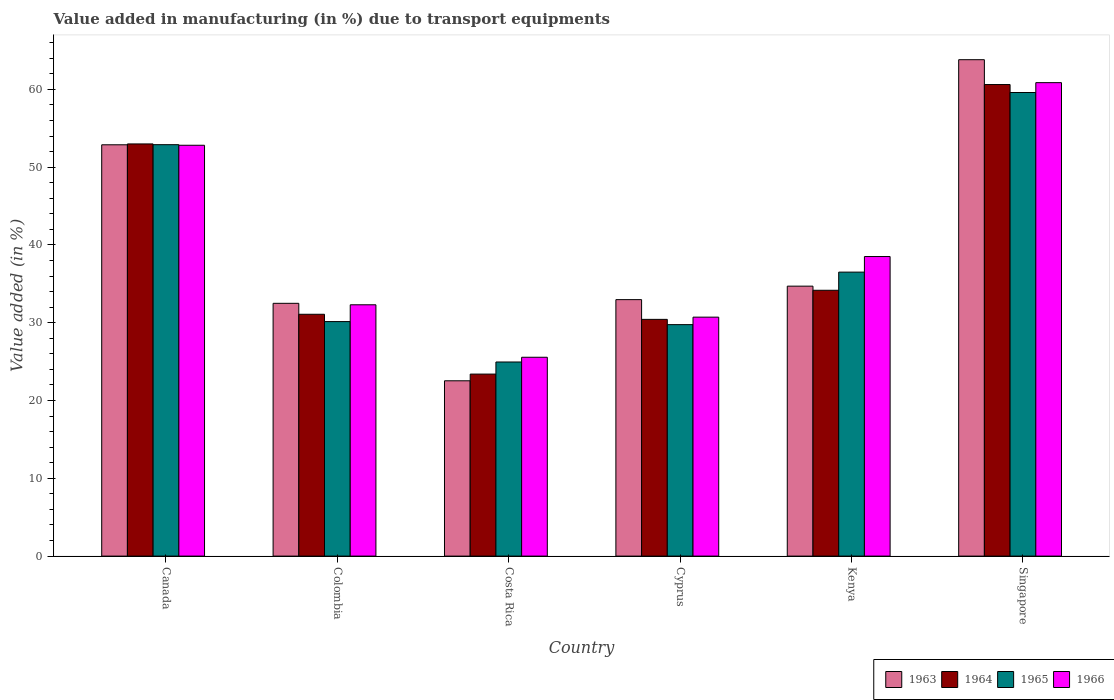How many different coloured bars are there?
Offer a terse response. 4. How many groups of bars are there?
Give a very brief answer. 6. Are the number of bars on each tick of the X-axis equal?
Give a very brief answer. Yes. How many bars are there on the 4th tick from the right?
Your answer should be compact. 4. What is the percentage of value added in manufacturing due to transport equipments in 1966 in Canada?
Keep it short and to the point. 52.81. Across all countries, what is the maximum percentage of value added in manufacturing due to transport equipments in 1964?
Provide a short and direct response. 60.62. Across all countries, what is the minimum percentage of value added in manufacturing due to transport equipments in 1966?
Your answer should be very brief. 25.56. In which country was the percentage of value added in manufacturing due to transport equipments in 1965 maximum?
Your answer should be compact. Singapore. What is the total percentage of value added in manufacturing due to transport equipments in 1966 in the graph?
Provide a succinct answer. 240.76. What is the difference between the percentage of value added in manufacturing due to transport equipments in 1966 in Canada and that in Kenya?
Ensure brevity in your answer.  14.3. What is the difference between the percentage of value added in manufacturing due to transport equipments in 1965 in Costa Rica and the percentage of value added in manufacturing due to transport equipments in 1963 in Singapore?
Provide a succinct answer. -38.86. What is the average percentage of value added in manufacturing due to transport equipments in 1966 per country?
Your answer should be compact. 40.13. What is the difference between the percentage of value added in manufacturing due to transport equipments of/in 1963 and percentage of value added in manufacturing due to transport equipments of/in 1964 in Costa Rica?
Provide a short and direct response. -0.86. In how many countries, is the percentage of value added in manufacturing due to transport equipments in 1964 greater than 52 %?
Give a very brief answer. 2. What is the ratio of the percentage of value added in manufacturing due to transport equipments in 1963 in Colombia to that in Singapore?
Provide a short and direct response. 0.51. What is the difference between the highest and the second highest percentage of value added in manufacturing due to transport equipments in 1964?
Ensure brevity in your answer.  -26.45. What is the difference between the highest and the lowest percentage of value added in manufacturing due to transport equipments in 1966?
Ensure brevity in your answer.  35.3. Is it the case that in every country, the sum of the percentage of value added in manufacturing due to transport equipments in 1965 and percentage of value added in manufacturing due to transport equipments in 1966 is greater than the sum of percentage of value added in manufacturing due to transport equipments in 1964 and percentage of value added in manufacturing due to transport equipments in 1963?
Offer a very short reply. No. What does the 3rd bar from the left in Costa Rica represents?
Your response must be concise. 1965. What does the 1st bar from the right in Singapore represents?
Offer a very short reply. 1966. How many bars are there?
Your response must be concise. 24. Are all the bars in the graph horizontal?
Provide a succinct answer. No. How many countries are there in the graph?
Provide a short and direct response. 6. Does the graph contain grids?
Your response must be concise. No. How are the legend labels stacked?
Give a very brief answer. Horizontal. What is the title of the graph?
Offer a very short reply. Value added in manufacturing (in %) due to transport equipments. Does "2013" appear as one of the legend labels in the graph?
Offer a very short reply. No. What is the label or title of the X-axis?
Ensure brevity in your answer.  Country. What is the label or title of the Y-axis?
Make the answer very short. Value added (in %). What is the Value added (in %) of 1963 in Canada?
Offer a very short reply. 52.87. What is the Value added (in %) of 1964 in Canada?
Ensure brevity in your answer.  52.98. What is the Value added (in %) of 1965 in Canada?
Make the answer very short. 52.89. What is the Value added (in %) of 1966 in Canada?
Provide a succinct answer. 52.81. What is the Value added (in %) in 1963 in Colombia?
Your answer should be compact. 32.49. What is the Value added (in %) in 1964 in Colombia?
Ensure brevity in your answer.  31.09. What is the Value added (in %) of 1965 in Colombia?
Provide a short and direct response. 30.15. What is the Value added (in %) in 1966 in Colombia?
Offer a terse response. 32.3. What is the Value added (in %) of 1963 in Costa Rica?
Your answer should be very brief. 22.53. What is the Value added (in %) of 1964 in Costa Rica?
Give a very brief answer. 23.4. What is the Value added (in %) in 1965 in Costa Rica?
Make the answer very short. 24.95. What is the Value added (in %) of 1966 in Costa Rica?
Make the answer very short. 25.56. What is the Value added (in %) in 1963 in Cyprus?
Offer a terse response. 32.97. What is the Value added (in %) in 1964 in Cyprus?
Ensure brevity in your answer.  30.43. What is the Value added (in %) in 1965 in Cyprus?
Keep it short and to the point. 29.75. What is the Value added (in %) of 1966 in Cyprus?
Offer a terse response. 30.72. What is the Value added (in %) in 1963 in Kenya?
Offer a very short reply. 34.7. What is the Value added (in %) of 1964 in Kenya?
Provide a short and direct response. 34.17. What is the Value added (in %) of 1965 in Kenya?
Ensure brevity in your answer.  36.5. What is the Value added (in %) of 1966 in Kenya?
Make the answer very short. 38.51. What is the Value added (in %) in 1963 in Singapore?
Provide a succinct answer. 63.81. What is the Value added (in %) in 1964 in Singapore?
Provide a succinct answer. 60.62. What is the Value added (in %) of 1965 in Singapore?
Your answer should be compact. 59.59. What is the Value added (in %) of 1966 in Singapore?
Ensure brevity in your answer.  60.86. Across all countries, what is the maximum Value added (in %) of 1963?
Your answer should be very brief. 63.81. Across all countries, what is the maximum Value added (in %) in 1964?
Ensure brevity in your answer.  60.62. Across all countries, what is the maximum Value added (in %) in 1965?
Your response must be concise. 59.59. Across all countries, what is the maximum Value added (in %) in 1966?
Ensure brevity in your answer.  60.86. Across all countries, what is the minimum Value added (in %) in 1963?
Make the answer very short. 22.53. Across all countries, what is the minimum Value added (in %) in 1964?
Give a very brief answer. 23.4. Across all countries, what is the minimum Value added (in %) in 1965?
Provide a succinct answer. 24.95. Across all countries, what is the minimum Value added (in %) of 1966?
Your answer should be compact. 25.56. What is the total Value added (in %) in 1963 in the graph?
Keep it short and to the point. 239.38. What is the total Value added (in %) in 1964 in the graph?
Provide a succinct answer. 232.68. What is the total Value added (in %) in 1965 in the graph?
Provide a short and direct response. 233.83. What is the total Value added (in %) of 1966 in the graph?
Make the answer very short. 240.76. What is the difference between the Value added (in %) in 1963 in Canada and that in Colombia?
Your response must be concise. 20.38. What is the difference between the Value added (in %) in 1964 in Canada and that in Colombia?
Ensure brevity in your answer.  21.9. What is the difference between the Value added (in %) of 1965 in Canada and that in Colombia?
Offer a very short reply. 22.74. What is the difference between the Value added (in %) of 1966 in Canada and that in Colombia?
Keep it short and to the point. 20.51. What is the difference between the Value added (in %) of 1963 in Canada and that in Costa Rica?
Ensure brevity in your answer.  30.34. What is the difference between the Value added (in %) of 1964 in Canada and that in Costa Rica?
Your answer should be compact. 29.59. What is the difference between the Value added (in %) in 1965 in Canada and that in Costa Rica?
Ensure brevity in your answer.  27.93. What is the difference between the Value added (in %) of 1966 in Canada and that in Costa Rica?
Keep it short and to the point. 27.25. What is the difference between the Value added (in %) of 1963 in Canada and that in Cyprus?
Your answer should be very brief. 19.91. What is the difference between the Value added (in %) of 1964 in Canada and that in Cyprus?
Give a very brief answer. 22.55. What is the difference between the Value added (in %) in 1965 in Canada and that in Cyprus?
Your response must be concise. 23.13. What is the difference between the Value added (in %) of 1966 in Canada and that in Cyprus?
Provide a short and direct response. 22.1. What is the difference between the Value added (in %) in 1963 in Canada and that in Kenya?
Offer a terse response. 18.17. What is the difference between the Value added (in %) in 1964 in Canada and that in Kenya?
Your answer should be compact. 18.81. What is the difference between the Value added (in %) in 1965 in Canada and that in Kenya?
Your answer should be very brief. 16.38. What is the difference between the Value added (in %) in 1966 in Canada and that in Kenya?
Keep it short and to the point. 14.3. What is the difference between the Value added (in %) of 1963 in Canada and that in Singapore?
Provide a short and direct response. -10.94. What is the difference between the Value added (in %) of 1964 in Canada and that in Singapore?
Ensure brevity in your answer.  -7.63. What is the difference between the Value added (in %) of 1965 in Canada and that in Singapore?
Provide a succinct answer. -6.71. What is the difference between the Value added (in %) of 1966 in Canada and that in Singapore?
Ensure brevity in your answer.  -8.05. What is the difference between the Value added (in %) in 1963 in Colombia and that in Costa Rica?
Offer a terse response. 9.96. What is the difference between the Value added (in %) in 1964 in Colombia and that in Costa Rica?
Provide a succinct answer. 7.69. What is the difference between the Value added (in %) in 1965 in Colombia and that in Costa Rica?
Offer a very short reply. 5.2. What is the difference between the Value added (in %) in 1966 in Colombia and that in Costa Rica?
Keep it short and to the point. 6.74. What is the difference between the Value added (in %) in 1963 in Colombia and that in Cyprus?
Make the answer very short. -0.47. What is the difference between the Value added (in %) of 1964 in Colombia and that in Cyprus?
Keep it short and to the point. 0.66. What is the difference between the Value added (in %) of 1965 in Colombia and that in Cyprus?
Your answer should be compact. 0.39. What is the difference between the Value added (in %) of 1966 in Colombia and that in Cyprus?
Give a very brief answer. 1.59. What is the difference between the Value added (in %) in 1963 in Colombia and that in Kenya?
Offer a terse response. -2.21. What is the difference between the Value added (in %) of 1964 in Colombia and that in Kenya?
Offer a very short reply. -3.08. What is the difference between the Value added (in %) of 1965 in Colombia and that in Kenya?
Your answer should be compact. -6.36. What is the difference between the Value added (in %) in 1966 in Colombia and that in Kenya?
Make the answer very short. -6.2. What is the difference between the Value added (in %) of 1963 in Colombia and that in Singapore?
Ensure brevity in your answer.  -31.32. What is the difference between the Value added (in %) of 1964 in Colombia and that in Singapore?
Your answer should be compact. -29.53. What is the difference between the Value added (in %) of 1965 in Colombia and that in Singapore?
Provide a succinct answer. -29.45. What is the difference between the Value added (in %) in 1966 in Colombia and that in Singapore?
Give a very brief answer. -28.56. What is the difference between the Value added (in %) of 1963 in Costa Rica and that in Cyprus?
Your answer should be very brief. -10.43. What is the difference between the Value added (in %) in 1964 in Costa Rica and that in Cyprus?
Your response must be concise. -7.03. What is the difference between the Value added (in %) in 1965 in Costa Rica and that in Cyprus?
Offer a very short reply. -4.8. What is the difference between the Value added (in %) in 1966 in Costa Rica and that in Cyprus?
Give a very brief answer. -5.16. What is the difference between the Value added (in %) in 1963 in Costa Rica and that in Kenya?
Provide a short and direct response. -12.17. What is the difference between the Value added (in %) in 1964 in Costa Rica and that in Kenya?
Your response must be concise. -10.77. What is the difference between the Value added (in %) of 1965 in Costa Rica and that in Kenya?
Ensure brevity in your answer.  -11.55. What is the difference between the Value added (in %) of 1966 in Costa Rica and that in Kenya?
Your response must be concise. -12.95. What is the difference between the Value added (in %) of 1963 in Costa Rica and that in Singapore?
Keep it short and to the point. -41.28. What is the difference between the Value added (in %) of 1964 in Costa Rica and that in Singapore?
Ensure brevity in your answer.  -37.22. What is the difference between the Value added (in %) in 1965 in Costa Rica and that in Singapore?
Your answer should be very brief. -34.64. What is the difference between the Value added (in %) in 1966 in Costa Rica and that in Singapore?
Your answer should be very brief. -35.3. What is the difference between the Value added (in %) of 1963 in Cyprus and that in Kenya?
Ensure brevity in your answer.  -1.73. What is the difference between the Value added (in %) of 1964 in Cyprus and that in Kenya?
Keep it short and to the point. -3.74. What is the difference between the Value added (in %) of 1965 in Cyprus and that in Kenya?
Provide a short and direct response. -6.75. What is the difference between the Value added (in %) of 1966 in Cyprus and that in Kenya?
Your response must be concise. -7.79. What is the difference between the Value added (in %) in 1963 in Cyprus and that in Singapore?
Provide a succinct answer. -30.84. What is the difference between the Value added (in %) of 1964 in Cyprus and that in Singapore?
Ensure brevity in your answer.  -30.19. What is the difference between the Value added (in %) of 1965 in Cyprus and that in Singapore?
Ensure brevity in your answer.  -29.84. What is the difference between the Value added (in %) of 1966 in Cyprus and that in Singapore?
Your response must be concise. -30.14. What is the difference between the Value added (in %) in 1963 in Kenya and that in Singapore?
Keep it short and to the point. -29.11. What is the difference between the Value added (in %) of 1964 in Kenya and that in Singapore?
Your answer should be compact. -26.45. What is the difference between the Value added (in %) in 1965 in Kenya and that in Singapore?
Give a very brief answer. -23.09. What is the difference between the Value added (in %) of 1966 in Kenya and that in Singapore?
Offer a terse response. -22.35. What is the difference between the Value added (in %) in 1963 in Canada and the Value added (in %) in 1964 in Colombia?
Keep it short and to the point. 21.79. What is the difference between the Value added (in %) of 1963 in Canada and the Value added (in %) of 1965 in Colombia?
Offer a very short reply. 22.73. What is the difference between the Value added (in %) in 1963 in Canada and the Value added (in %) in 1966 in Colombia?
Keep it short and to the point. 20.57. What is the difference between the Value added (in %) in 1964 in Canada and the Value added (in %) in 1965 in Colombia?
Keep it short and to the point. 22.84. What is the difference between the Value added (in %) in 1964 in Canada and the Value added (in %) in 1966 in Colombia?
Your response must be concise. 20.68. What is the difference between the Value added (in %) in 1965 in Canada and the Value added (in %) in 1966 in Colombia?
Your response must be concise. 20.58. What is the difference between the Value added (in %) of 1963 in Canada and the Value added (in %) of 1964 in Costa Rica?
Provide a short and direct response. 29.48. What is the difference between the Value added (in %) in 1963 in Canada and the Value added (in %) in 1965 in Costa Rica?
Keep it short and to the point. 27.92. What is the difference between the Value added (in %) in 1963 in Canada and the Value added (in %) in 1966 in Costa Rica?
Provide a short and direct response. 27.31. What is the difference between the Value added (in %) of 1964 in Canada and the Value added (in %) of 1965 in Costa Rica?
Your answer should be very brief. 28.03. What is the difference between the Value added (in %) of 1964 in Canada and the Value added (in %) of 1966 in Costa Rica?
Keep it short and to the point. 27.42. What is the difference between the Value added (in %) in 1965 in Canada and the Value added (in %) in 1966 in Costa Rica?
Keep it short and to the point. 27.33. What is the difference between the Value added (in %) in 1963 in Canada and the Value added (in %) in 1964 in Cyprus?
Your answer should be compact. 22.44. What is the difference between the Value added (in %) of 1963 in Canada and the Value added (in %) of 1965 in Cyprus?
Your response must be concise. 23.12. What is the difference between the Value added (in %) in 1963 in Canada and the Value added (in %) in 1966 in Cyprus?
Ensure brevity in your answer.  22.16. What is the difference between the Value added (in %) of 1964 in Canada and the Value added (in %) of 1965 in Cyprus?
Your answer should be very brief. 23.23. What is the difference between the Value added (in %) of 1964 in Canada and the Value added (in %) of 1966 in Cyprus?
Your answer should be compact. 22.27. What is the difference between the Value added (in %) of 1965 in Canada and the Value added (in %) of 1966 in Cyprus?
Keep it short and to the point. 22.17. What is the difference between the Value added (in %) in 1963 in Canada and the Value added (in %) in 1964 in Kenya?
Ensure brevity in your answer.  18.7. What is the difference between the Value added (in %) of 1963 in Canada and the Value added (in %) of 1965 in Kenya?
Offer a very short reply. 16.37. What is the difference between the Value added (in %) of 1963 in Canada and the Value added (in %) of 1966 in Kenya?
Provide a short and direct response. 14.37. What is the difference between the Value added (in %) in 1964 in Canada and the Value added (in %) in 1965 in Kenya?
Provide a short and direct response. 16.48. What is the difference between the Value added (in %) of 1964 in Canada and the Value added (in %) of 1966 in Kenya?
Offer a terse response. 14.47. What is the difference between the Value added (in %) of 1965 in Canada and the Value added (in %) of 1966 in Kenya?
Make the answer very short. 14.38. What is the difference between the Value added (in %) of 1963 in Canada and the Value added (in %) of 1964 in Singapore?
Your response must be concise. -7.74. What is the difference between the Value added (in %) of 1963 in Canada and the Value added (in %) of 1965 in Singapore?
Your response must be concise. -6.72. What is the difference between the Value added (in %) of 1963 in Canada and the Value added (in %) of 1966 in Singapore?
Keep it short and to the point. -7.99. What is the difference between the Value added (in %) in 1964 in Canada and the Value added (in %) in 1965 in Singapore?
Offer a very short reply. -6.61. What is the difference between the Value added (in %) in 1964 in Canada and the Value added (in %) in 1966 in Singapore?
Provide a succinct answer. -7.88. What is the difference between the Value added (in %) in 1965 in Canada and the Value added (in %) in 1966 in Singapore?
Ensure brevity in your answer.  -7.97. What is the difference between the Value added (in %) of 1963 in Colombia and the Value added (in %) of 1964 in Costa Rica?
Give a very brief answer. 9.1. What is the difference between the Value added (in %) of 1963 in Colombia and the Value added (in %) of 1965 in Costa Rica?
Offer a very short reply. 7.54. What is the difference between the Value added (in %) of 1963 in Colombia and the Value added (in %) of 1966 in Costa Rica?
Your answer should be compact. 6.93. What is the difference between the Value added (in %) of 1964 in Colombia and the Value added (in %) of 1965 in Costa Rica?
Your answer should be compact. 6.14. What is the difference between the Value added (in %) of 1964 in Colombia and the Value added (in %) of 1966 in Costa Rica?
Keep it short and to the point. 5.53. What is the difference between the Value added (in %) of 1965 in Colombia and the Value added (in %) of 1966 in Costa Rica?
Ensure brevity in your answer.  4.59. What is the difference between the Value added (in %) in 1963 in Colombia and the Value added (in %) in 1964 in Cyprus?
Offer a terse response. 2.06. What is the difference between the Value added (in %) in 1963 in Colombia and the Value added (in %) in 1965 in Cyprus?
Ensure brevity in your answer.  2.74. What is the difference between the Value added (in %) of 1963 in Colombia and the Value added (in %) of 1966 in Cyprus?
Offer a very short reply. 1.78. What is the difference between the Value added (in %) of 1964 in Colombia and the Value added (in %) of 1965 in Cyprus?
Provide a short and direct response. 1.33. What is the difference between the Value added (in %) of 1964 in Colombia and the Value added (in %) of 1966 in Cyprus?
Make the answer very short. 0.37. What is the difference between the Value added (in %) of 1965 in Colombia and the Value added (in %) of 1966 in Cyprus?
Make the answer very short. -0.57. What is the difference between the Value added (in %) in 1963 in Colombia and the Value added (in %) in 1964 in Kenya?
Give a very brief answer. -1.68. What is the difference between the Value added (in %) in 1963 in Colombia and the Value added (in %) in 1965 in Kenya?
Offer a very short reply. -4.01. What is the difference between the Value added (in %) in 1963 in Colombia and the Value added (in %) in 1966 in Kenya?
Offer a very short reply. -6.01. What is the difference between the Value added (in %) in 1964 in Colombia and the Value added (in %) in 1965 in Kenya?
Offer a very short reply. -5.42. What is the difference between the Value added (in %) of 1964 in Colombia and the Value added (in %) of 1966 in Kenya?
Your response must be concise. -7.42. What is the difference between the Value added (in %) in 1965 in Colombia and the Value added (in %) in 1966 in Kenya?
Offer a very short reply. -8.36. What is the difference between the Value added (in %) in 1963 in Colombia and the Value added (in %) in 1964 in Singapore?
Offer a very short reply. -28.12. What is the difference between the Value added (in %) in 1963 in Colombia and the Value added (in %) in 1965 in Singapore?
Keep it short and to the point. -27.1. What is the difference between the Value added (in %) of 1963 in Colombia and the Value added (in %) of 1966 in Singapore?
Offer a very short reply. -28.37. What is the difference between the Value added (in %) in 1964 in Colombia and the Value added (in %) in 1965 in Singapore?
Provide a short and direct response. -28.51. What is the difference between the Value added (in %) of 1964 in Colombia and the Value added (in %) of 1966 in Singapore?
Make the answer very short. -29.77. What is the difference between the Value added (in %) in 1965 in Colombia and the Value added (in %) in 1966 in Singapore?
Offer a terse response. -30.71. What is the difference between the Value added (in %) in 1963 in Costa Rica and the Value added (in %) in 1964 in Cyprus?
Give a very brief answer. -7.9. What is the difference between the Value added (in %) of 1963 in Costa Rica and the Value added (in %) of 1965 in Cyprus?
Offer a very short reply. -7.22. What is the difference between the Value added (in %) in 1963 in Costa Rica and the Value added (in %) in 1966 in Cyprus?
Your answer should be very brief. -8.18. What is the difference between the Value added (in %) in 1964 in Costa Rica and the Value added (in %) in 1965 in Cyprus?
Your response must be concise. -6.36. What is the difference between the Value added (in %) in 1964 in Costa Rica and the Value added (in %) in 1966 in Cyprus?
Give a very brief answer. -7.32. What is the difference between the Value added (in %) of 1965 in Costa Rica and the Value added (in %) of 1966 in Cyprus?
Provide a short and direct response. -5.77. What is the difference between the Value added (in %) of 1963 in Costa Rica and the Value added (in %) of 1964 in Kenya?
Give a very brief answer. -11.64. What is the difference between the Value added (in %) of 1963 in Costa Rica and the Value added (in %) of 1965 in Kenya?
Your answer should be very brief. -13.97. What is the difference between the Value added (in %) of 1963 in Costa Rica and the Value added (in %) of 1966 in Kenya?
Give a very brief answer. -15.97. What is the difference between the Value added (in %) in 1964 in Costa Rica and the Value added (in %) in 1965 in Kenya?
Your answer should be very brief. -13.11. What is the difference between the Value added (in %) of 1964 in Costa Rica and the Value added (in %) of 1966 in Kenya?
Keep it short and to the point. -15.11. What is the difference between the Value added (in %) of 1965 in Costa Rica and the Value added (in %) of 1966 in Kenya?
Offer a terse response. -13.56. What is the difference between the Value added (in %) in 1963 in Costa Rica and the Value added (in %) in 1964 in Singapore?
Offer a terse response. -38.08. What is the difference between the Value added (in %) of 1963 in Costa Rica and the Value added (in %) of 1965 in Singapore?
Ensure brevity in your answer.  -37.06. What is the difference between the Value added (in %) in 1963 in Costa Rica and the Value added (in %) in 1966 in Singapore?
Your answer should be very brief. -38.33. What is the difference between the Value added (in %) in 1964 in Costa Rica and the Value added (in %) in 1965 in Singapore?
Give a very brief answer. -36.19. What is the difference between the Value added (in %) of 1964 in Costa Rica and the Value added (in %) of 1966 in Singapore?
Offer a terse response. -37.46. What is the difference between the Value added (in %) of 1965 in Costa Rica and the Value added (in %) of 1966 in Singapore?
Your response must be concise. -35.91. What is the difference between the Value added (in %) of 1963 in Cyprus and the Value added (in %) of 1964 in Kenya?
Provide a short and direct response. -1.2. What is the difference between the Value added (in %) of 1963 in Cyprus and the Value added (in %) of 1965 in Kenya?
Give a very brief answer. -3.54. What is the difference between the Value added (in %) in 1963 in Cyprus and the Value added (in %) in 1966 in Kenya?
Your answer should be very brief. -5.54. What is the difference between the Value added (in %) in 1964 in Cyprus and the Value added (in %) in 1965 in Kenya?
Your response must be concise. -6.07. What is the difference between the Value added (in %) of 1964 in Cyprus and the Value added (in %) of 1966 in Kenya?
Offer a terse response. -8.08. What is the difference between the Value added (in %) of 1965 in Cyprus and the Value added (in %) of 1966 in Kenya?
Make the answer very short. -8.75. What is the difference between the Value added (in %) of 1963 in Cyprus and the Value added (in %) of 1964 in Singapore?
Provide a succinct answer. -27.65. What is the difference between the Value added (in %) in 1963 in Cyprus and the Value added (in %) in 1965 in Singapore?
Offer a very short reply. -26.62. What is the difference between the Value added (in %) of 1963 in Cyprus and the Value added (in %) of 1966 in Singapore?
Your answer should be very brief. -27.89. What is the difference between the Value added (in %) in 1964 in Cyprus and the Value added (in %) in 1965 in Singapore?
Make the answer very short. -29.16. What is the difference between the Value added (in %) in 1964 in Cyprus and the Value added (in %) in 1966 in Singapore?
Provide a short and direct response. -30.43. What is the difference between the Value added (in %) of 1965 in Cyprus and the Value added (in %) of 1966 in Singapore?
Your response must be concise. -31.11. What is the difference between the Value added (in %) in 1963 in Kenya and the Value added (in %) in 1964 in Singapore?
Ensure brevity in your answer.  -25.92. What is the difference between the Value added (in %) of 1963 in Kenya and the Value added (in %) of 1965 in Singapore?
Your answer should be very brief. -24.89. What is the difference between the Value added (in %) of 1963 in Kenya and the Value added (in %) of 1966 in Singapore?
Provide a succinct answer. -26.16. What is the difference between the Value added (in %) in 1964 in Kenya and the Value added (in %) in 1965 in Singapore?
Your answer should be compact. -25.42. What is the difference between the Value added (in %) in 1964 in Kenya and the Value added (in %) in 1966 in Singapore?
Your response must be concise. -26.69. What is the difference between the Value added (in %) in 1965 in Kenya and the Value added (in %) in 1966 in Singapore?
Offer a very short reply. -24.36. What is the average Value added (in %) of 1963 per country?
Make the answer very short. 39.9. What is the average Value added (in %) of 1964 per country?
Your answer should be compact. 38.78. What is the average Value added (in %) of 1965 per country?
Give a very brief answer. 38.97. What is the average Value added (in %) of 1966 per country?
Make the answer very short. 40.13. What is the difference between the Value added (in %) of 1963 and Value added (in %) of 1964 in Canada?
Offer a very short reply. -0.11. What is the difference between the Value added (in %) in 1963 and Value added (in %) in 1965 in Canada?
Your answer should be very brief. -0.01. What is the difference between the Value added (in %) in 1963 and Value added (in %) in 1966 in Canada?
Your answer should be compact. 0.06. What is the difference between the Value added (in %) of 1964 and Value added (in %) of 1965 in Canada?
Give a very brief answer. 0.1. What is the difference between the Value added (in %) of 1964 and Value added (in %) of 1966 in Canada?
Your response must be concise. 0.17. What is the difference between the Value added (in %) in 1965 and Value added (in %) in 1966 in Canada?
Make the answer very short. 0.07. What is the difference between the Value added (in %) in 1963 and Value added (in %) in 1964 in Colombia?
Offer a very short reply. 1.41. What is the difference between the Value added (in %) in 1963 and Value added (in %) in 1965 in Colombia?
Your answer should be compact. 2.35. What is the difference between the Value added (in %) of 1963 and Value added (in %) of 1966 in Colombia?
Provide a short and direct response. 0.19. What is the difference between the Value added (in %) in 1964 and Value added (in %) in 1965 in Colombia?
Your response must be concise. 0.94. What is the difference between the Value added (in %) in 1964 and Value added (in %) in 1966 in Colombia?
Offer a terse response. -1.22. What is the difference between the Value added (in %) in 1965 and Value added (in %) in 1966 in Colombia?
Offer a terse response. -2.16. What is the difference between the Value added (in %) in 1963 and Value added (in %) in 1964 in Costa Rica?
Offer a terse response. -0.86. What is the difference between the Value added (in %) of 1963 and Value added (in %) of 1965 in Costa Rica?
Keep it short and to the point. -2.42. What is the difference between the Value added (in %) in 1963 and Value added (in %) in 1966 in Costa Rica?
Give a very brief answer. -3.03. What is the difference between the Value added (in %) of 1964 and Value added (in %) of 1965 in Costa Rica?
Your answer should be very brief. -1.55. What is the difference between the Value added (in %) in 1964 and Value added (in %) in 1966 in Costa Rica?
Keep it short and to the point. -2.16. What is the difference between the Value added (in %) in 1965 and Value added (in %) in 1966 in Costa Rica?
Keep it short and to the point. -0.61. What is the difference between the Value added (in %) in 1963 and Value added (in %) in 1964 in Cyprus?
Give a very brief answer. 2.54. What is the difference between the Value added (in %) of 1963 and Value added (in %) of 1965 in Cyprus?
Your response must be concise. 3.21. What is the difference between the Value added (in %) of 1963 and Value added (in %) of 1966 in Cyprus?
Your answer should be compact. 2.25. What is the difference between the Value added (in %) in 1964 and Value added (in %) in 1965 in Cyprus?
Provide a succinct answer. 0.68. What is the difference between the Value added (in %) in 1964 and Value added (in %) in 1966 in Cyprus?
Provide a succinct answer. -0.29. What is the difference between the Value added (in %) of 1965 and Value added (in %) of 1966 in Cyprus?
Give a very brief answer. -0.96. What is the difference between the Value added (in %) in 1963 and Value added (in %) in 1964 in Kenya?
Offer a very short reply. 0.53. What is the difference between the Value added (in %) of 1963 and Value added (in %) of 1965 in Kenya?
Give a very brief answer. -1.8. What is the difference between the Value added (in %) in 1963 and Value added (in %) in 1966 in Kenya?
Your response must be concise. -3.81. What is the difference between the Value added (in %) of 1964 and Value added (in %) of 1965 in Kenya?
Offer a very short reply. -2.33. What is the difference between the Value added (in %) of 1964 and Value added (in %) of 1966 in Kenya?
Your response must be concise. -4.34. What is the difference between the Value added (in %) of 1965 and Value added (in %) of 1966 in Kenya?
Give a very brief answer. -2. What is the difference between the Value added (in %) in 1963 and Value added (in %) in 1964 in Singapore?
Offer a terse response. 3.19. What is the difference between the Value added (in %) in 1963 and Value added (in %) in 1965 in Singapore?
Offer a terse response. 4.22. What is the difference between the Value added (in %) of 1963 and Value added (in %) of 1966 in Singapore?
Give a very brief answer. 2.95. What is the difference between the Value added (in %) of 1964 and Value added (in %) of 1965 in Singapore?
Your answer should be compact. 1.03. What is the difference between the Value added (in %) in 1964 and Value added (in %) in 1966 in Singapore?
Offer a very short reply. -0.24. What is the difference between the Value added (in %) of 1965 and Value added (in %) of 1966 in Singapore?
Your answer should be very brief. -1.27. What is the ratio of the Value added (in %) of 1963 in Canada to that in Colombia?
Make the answer very short. 1.63. What is the ratio of the Value added (in %) in 1964 in Canada to that in Colombia?
Provide a short and direct response. 1.7. What is the ratio of the Value added (in %) in 1965 in Canada to that in Colombia?
Make the answer very short. 1.75. What is the ratio of the Value added (in %) in 1966 in Canada to that in Colombia?
Keep it short and to the point. 1.63. What is the ratio of the Value added (in %) in 1963 in Canada to that in Costa Rica?
Provide a succinct answer. 2.35. What is the ratio of the Value added (in %) in 1964 in Canada to that in Costa Rica?
Offer a terse response. 2.26. What is the ratio of the Value added (in %) in 1965 in Canada to that in Costa Rica?
Keep it short and to the point. 2.12. What is the ratio of the Value added (in %) in 1966 in Canada to that in Costa Rica?
Provide a short and direct response. 2.07. What is the ratio of the Value added (in %) in 1963 in Canada to that in Cyprus?
Your answer should be compact. 1.6. What is the ratio of the Value added (in %) in 1964 in Canada to that in Cyprus?
Keep it short and to the point. 1.74. What is the ratio of the Value added (in %) in 1965 in Canada to that in Cyprus?
Ensure brevity in your answer.  1.78. What is the ratio of the Value added (in %) of 1966 in Canada to that in Cyprus?
Offer a terse response. 1.72. What is the ratio of the Value added (in %) in 1963 in Canada to that in Kenya?
Offer a very short reply. 1.52. What is the ratio of the Value added (in %) of 1964 in Canada to that in Kenya?
Offer a very short reply. 1.55. What is the ratio of the Value added (in %) in 1965 in Canada to that in Kenya?
Offer a very short reply. 1.45. What is the ratio of the Value added (in %) of 1966 in Canada to that in Kenya?
Your response must be concise. 1.37. What is the ratio of the Value added (in %) of 1963 in Canada to that in Singapore?
Keep it short and to the point. 0.83. What is the ratio of the Value added (in %) in 1964 in Canada to that in Singapore?
Offer a terse response. 0.87. What is the ratio of the Value added (in %) of 1965 in Canada to that in Singapore?
Provide a succinct answer. 0.89. What is the ratio of the Value added (in %) in 1966 in Canada to that in Singapore?
Provide a short and direct response. 0.87. What is the ratio of the Value added (in %) in 1963 in Colombia to that in Costa Rica?
Provide a short and direct response. 1.44. What is the ratio of the Value added (in %) in 1964 in Colombia to that in Costa Rica?
Provide a short and direct response. 1.33. What is the ratio of the Value added (in %) of 1965 in Colombia to that in Costa Rica?
Offer a terse response. 1.21. What is the ratio of the Value added (in %) in 1966 in Colombia to that in Costa Rica?
Keep it short and to the point. 1.26. What is the ratio of the Value added (in %) of 1963 in Colombia to that in Cyprus?
Your response must be concise. 0.99. What is the ratio of the Value added (in %) in 1964 in Colombia to that in Cyprus?
Your answer should be compact. 1.02. What is the ratio of the Value added (in %) of 1965 in Colombia to that in Cyprus?
Make the answer very short. 1.01. What is the ratio of the Value added (in %) in 1966 in Colombia to that in Cyprus?
Offer a terse response. 1.05. What is the ratio of the Value added (in %) of 1963 in Colombia to that in Kenya?
Give a very brief answer. 0.94. What is the ratio of the Value added (in %) of 1964 in Colombia to that in Kenya?
Offer a very short reply. 0.91. What is the ratio of the Value added (in %) in 1965 in Colombia to that in Kenya?
Ensure brevity in your answer.  0.83. What is the ratio of the Value added (in %) in 1966 in Colombia to that in Kenya?
Give a very brief answer. 0.84. What is the ratio of the Value added (in %) in 1963 in Colombia to that in Singapore?
Make the answer very short. 0.51. What is the ratio of the Value added (in %) of 1964 in Colombia to that in Singapore?
Give a very brief answer. 0.51. What is the ratio of the Value added (in %) in 1965 in Colombia to that in Singapore?
Give a very brief answer. 0.51. What is the ratio of the Value added (in %) of 1966 in Colombia to that in Singapore?
Your answer should be compact. 0.53. What is the ratio of the Value added (in %) in 1963 in Costa Rica to that in Cyprus?
Your answer should be very brief. 0.68. What is the ratio of the Value added (in %) in 1964 in Costa Rica to that in Cyprus?
Offer a terse response. 0.77. What is the ratio of the Value added (in %) of 1965 in Costa Rica to that in Cyprus?
Provide a short and direct response. 0.84. What is the ratio of the Value added (in %) of 1966 in Costa Rica to that in Cyprus?
Offer a very short reply. 0.83. What is the ratio of the Value added (in %) in 1963 in Costa Rica to that in Kenya?
Offer a terse response. 0.65. What is the ratio of the Value added (in %) in 1964 in Costa Rica to that in Kenya?
Offer a very short reply. 0.68. What is the ratio of the Value added (in %) in 1965 in Costa Rica to that in Kenya?
Make the answer very short. 0.68. What is the ratio of the Value added (in %) of 1966 in Costa Rica to that in Kenya?
Offer a terse response. 0.66. What is the ratio of the Value added (in %) in 1963 in Costa Rica to that in Singapore?
Your response must be concise. 0.35. What is the ratio of the Value added (in %) in 1964 in Costa Rica to that in Singapore?
Keep it short and to the point. 0.39. What is the ratio of the Value added (in %) in 1965 in Costa Rica to that in Singapore?
Ensure brevity in your answer.  0.42. What is the ratio of the Value added (in %) in 1966 in Costa Rica to that in Singapore?
Provide a succinct answer. 0.42. What is the ratio of the Value added (in %) in 1963 in Cyprus to that in Kenya?
Provide a short and direct response. 0.95. What is the ratio of the Value added (in %) of 1964 in Cyprus to that in Kenya?
Provide a short and direct response. 0.89. What is the ratio of the Value added (in %) in 1965 in Cyprus to that in Kenya?
Offer a terse response. 0.82. What is the ratio of the Value added (in %) in 1966 in Cyprus to that in Kenya?
Provide a succinct answer. 0.8. What is the ratio of the Value added (in %) of 1963 in Cyprus to that in Singapore?
Make the answer very short. 0.52. What is the ratio of the Value added (in %) of 1964 in Cyprus to that in Singapore?
Your answer should be compact. 0.5. What is the ratio of the Value added (in %) of 1965 in Cyprus to that in Singapore?
Offer a very short reply. 0.5. What is the ratio of the Value added (in %) in 1966 in Cyprus to that in Singapore?
Make the answer very short. 0.5. What is the ratio of the Value added (in %) of 1963 in Kenya to that in Singapore?
Your response must be concise. 0.54. What is the ratio of the Value added (in %) in 1964 in Kenya to that in Singapore?
Keep it short and to the point. 0.56. What is the ratio of the Value added (in %) of 1965 in Kenya to that in Singapore?
Your answer should be very brief. 0.61. What is the ratio of the Value added (in %) in 1966 in Kenya to that in Singapore?
Offer a terse response. 0.63. What is the difference between the highest and the second highest Value added (in %) in 1963?
Provide a succinct answer. 10.94. What is the difference between the highest and the second highest Value added (in %) of 1964?
Your answer should be compact. 7.63. What is the difference between the highest and the second highest Value added (in %) of 1965?
Your answer should be very brief. 6.71. What is the difference between the highest and the second highest Value added (in %) in 1966?
Give a very brief answer. 8.05. What is the difference between the highest and the lowest Value added (in %) in 1963?
Make the answer very short. 41.28. What is the difference between the highest and the lowest Value added (in %) of 1964?
Your answer should be compact. 37.22. What is the difference between the highest and the lowest Value added (in %) of 1965?
Offer a terse response. 34.64. What is the difference between the highest and the lowest Value added (in %) in 1966?
Provide a short and direct response. 35.3. 